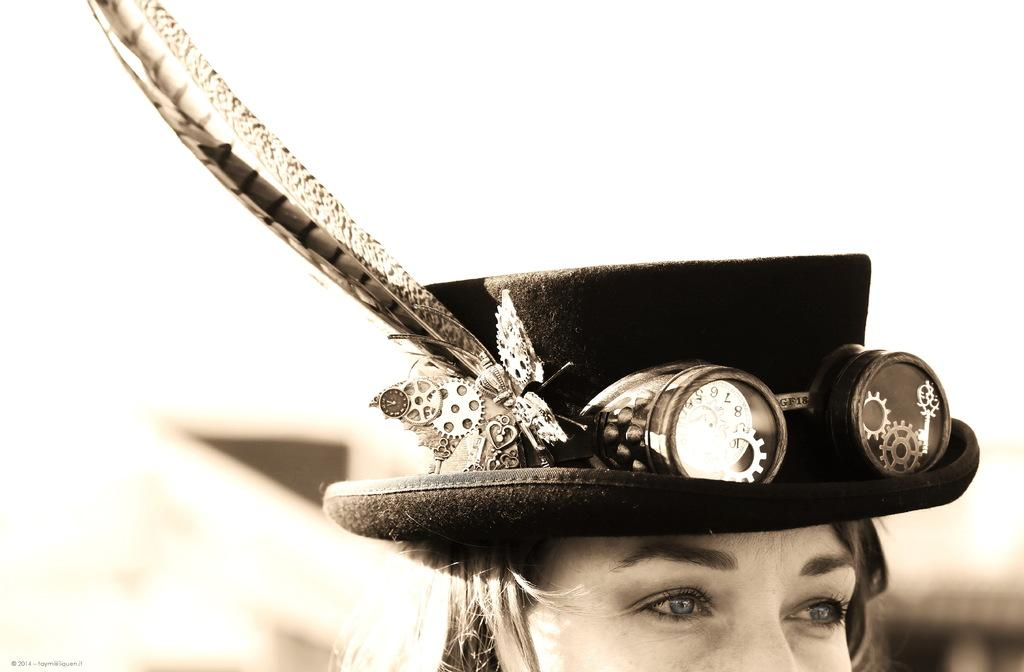Who is the main subject in the image? There is a girl in the image. What is the girl wearing on her head? The girl is wearing a hat on her head. Can you describe the background of the image? The background of the image is blurred. How many grapes are on the girl's hat in the image? There are no grapes present on the girl's hat in the image. Are there any bikes visible in the image? There are no bikes visible in the image. 